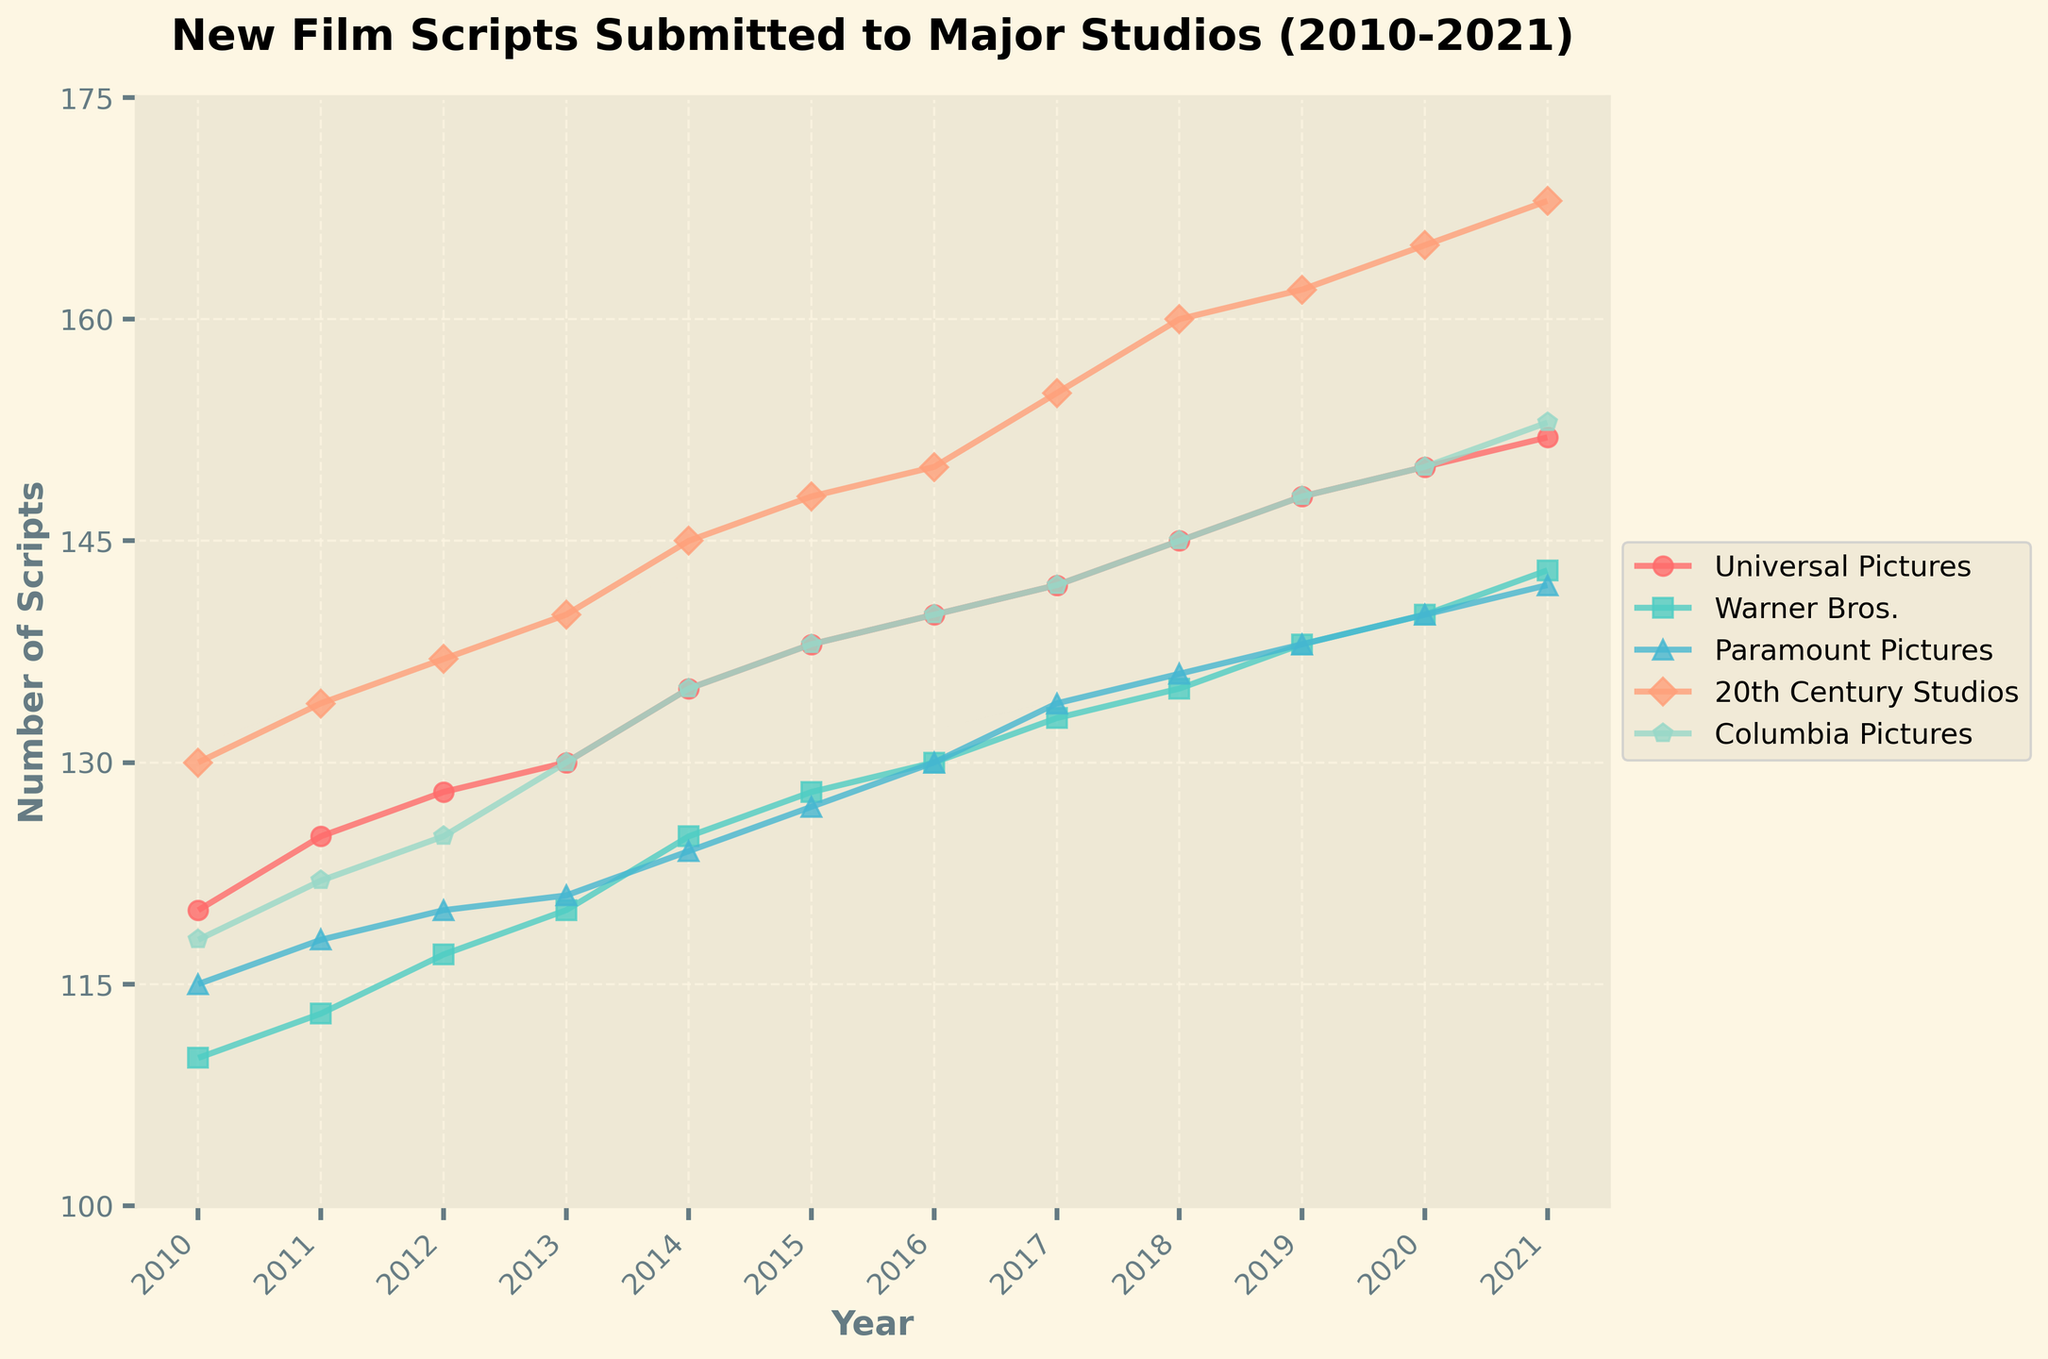What is the title of the plot? The title is located at the top of the plot and is written in bold. It reads "New Film Scripts Submitted to Major Studios (2010-2021)."
Answer: New Film Scripts Submitted to Major Studios (2010-2021) What is the number of new film scripts submitted to Universal Pictures in 2016? Trace the line corresponding to Universal Pictures and find the data point above the year 2016. The value is 140.
Answer: 140 Which studio had the highest number of new film scripts submitted in 2021? Look at the data points for all studios above the year 2021 and find the highest value. 20th Century Studios had 168 submissions, which is the highest.
Answer: 20th Century Studios How did the number of new film scripts submitted to Columbia Pictures change from 2014 to 2015? Check the data points for Columbia Pictures in the years 2014 and 2015. In 2014, there were 135 submissions, and in 2015, there were 138 submissions. The change is 138 - 135 = 3.
Answer: Increased by 3 Which studio showed a consistent increase in new film scripts submissions every year? Analyze the trend lines of all studios. Only Columbia Pictures shows a consistent year-by-year increase throughout the entire period.
Answer: Columbia Pictures What is the difference in the number of new film scripts submitted to Warner Bros. between 2010 and 2021? Identify the submissions for Warner Bros. in 2010 (110) and 2021 (143) and calculate the difference: 143 - 110 = 33.
Answer: 33 In which year did Paramount Pictures receive the same number of submissions as Columbia Pictures? Look for years when Paramount Pictures and Columbia Pictures have data points at the same level. Both had 127 submissions in 2015.
Answer: 2015 On average, how many new scripts per year were submitted to 20th Century Studios from 2010 to 2021? Sum the submission values for 20th Century Studios from 2010 to 2021 (130 + 134 + 137 + 140 + 145 + 148 + 150 + 155 + 160 + 162 + 165 + 168 = 1794), then divide by the number of years (1794 / 12 = 149.5).
Answer: 149.5 What was the trend in new script submissions to Universal Pictures from 2010 to 2021? Observe the line for Universal Pictures. It shows a steady increase from 120 submissions in 2010 to 152 submissions in 2021.
Answer: Steady increase Which studio had the most significant increase in submissions from 2010 to 2021? Calculate the increase for each studio:
- Universal Pictures: 152 - 120 = 32
- Warner Bros.: 143 - 110 = 33
- Paramount Pictures: 142 - 115 = 27
- 20th Century Studios: 168 - 130 = 38
- Columbia Pictures: 153 - 118 = 35
The greatest increase is for 20th Century Studios with 38.
Answer: 20th Century Studios 